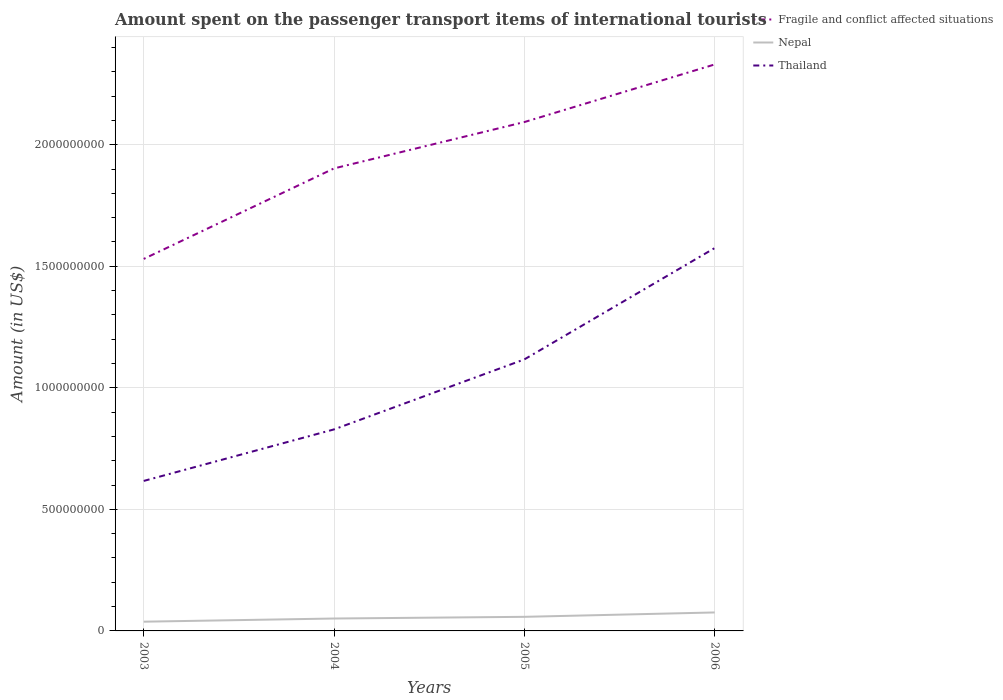Is the number of lines equal to the number of legend labels?
Offer a very short reply. Yes. Across all years, what is the maximum amount spent on the passenger transport items of international tourists in Nepal?
Provide a succinct answer. 3.80e+07. In which year was the amount spent on the passenger transport items of international tourists in Fragile and conflict affected situations maximum?
Your answer should be very brief. 2003. What is the total amount spent on the passenger transport items of international tourists in Nepal in the graph?
Your answer should be very brief. -1.30e+07. What is the difference between the highest and the second highest amount spent on the passenger transport items of international tourists in Fragile and conflict affected situations?
Provide a succinct answer. 8.00e+08. Is the amount spent on the passenger transport items of international tourists in Nepal strictly greater than the amount spent on the passenger transport items of international tourists in Fragile and conflict affected situations over the years?
Provide a succinct answer. Yes. How many lines are there?
Your answer should be compact. 3. Are the values on the major ticks of Y-axis written in scientific E-notation?
Offer a terse response. No. What is the title of the graph?
Your answer should be very brief. Amount spent on the passenger transport items of international tourists. Does "Gambia, The" appear as one of the legend labels in the graph?
Give a very brief answer. No. What is the Amount (in US$) in Fragile and conflict affected situations in 2003?
Ensure brevity in your answer.  1.53e+09. What is the Amount (in US$) in Nepal in 2003?
Make the answer very short. 3.80e+07. What is the Amount (in US$) in Thailand in 2003?
Keep it short and to the point. 6.17e+08. What is the Amount (in US$) in Fragile and conflict affected situations in 2004?
Offer a terse response. 1.90e+09. What is the Amount (in US$) in Nepal in 2004?
Make the answer very short. 5.10e+07. What is the Amount (in US$) in Thailand in 2004?
Keep it short and to the point. 8.29e+08. What is the Amount (in US$) of Fragile and conflict affected situations in 2005?
Your answer should be very brief. 2.09e+09. What is the Amount (in US$) of Nepal in 2005?
Provide a succinct answer. 5.80e+07. What is the Amount (in US$) in Thailand in 2005?
Provide a succinct answer. 1.12e+09. What is the Amount (in US$) in Fragile and conflict affected situations in 2006?
Offer a very short reply. 2.33e+09. What is the Amount (in US$) in Nepal in 2006?
Your answer should be compact. 7.60e+07. What is the Amount (in US$) of Thailand in 2006?
Your answer should be compact. 1.58e+09. Across all years, what is the maximum Amount (in US$) of Fragile and conflict affected situations?
Keep it short and to the point. 2.33e+09. Across all years, what is the maximum Amount (in US$) of Nepal?
Your answer should be very brief. 7.60e+07. Across all years, what is the maximum Amount (in US$) in Thailand?
Offer a terse response. 1.58e+09. Across all years, what is the minimum Amount (in US$) of Fragile and conflict affected situations?
Offer a very short reply. 1.53e+09. Across all years, what is the minimum Amount (in US$) of Nepal?
Your answer should be very brief. 3.80e+07. Across all years, what is the minimum Amount (in US$) of Thailand?
Offer a very short reply. 6.17e+08. What is the total Amount (in US$) of Fragile and conflict affected situations in the graph?
Ensure brevity in your answer.  7.86e+09. What is the total Amount (in US$) in Nepal in the graph?
Keep it short and to the point. 2.23e+08. What is the total Amount (in US$) in Thailand in the graph?
Make the answer very short. 4.14e+09. What is the difference between the Amount (in US$) of Fragile and conflict affected situations in 2003 and that in 2004?
Make the answer very short. -3.72e+08. What is the difference between the Amount (in US$) in Nepal in 2003 and that in 2004?
Provide a succinct answer. -1.30e+07. What is the difference between the Amount (in US$) of Thailand in 2003 and that in 2004?
Give a very brief answer. -2.12e+08. What is the difference between the Amount (in US$) of Fragile and conflict affected situations in 2003 and that in 2005?
Your answer should be very brief. -5.63e+08. What is the difference between the Amount (in US$) of Nepal in 2003 and that in 2005?
Give a very brief answer. -2.00e+07. What is the difference between the Amount (in US$) of Thailand in 2003 and that in 2005?
Ensure brevity in your answer.  -5.00e+08. What is the difference between the Amount (in US$) in Fragile and conflict affected situations in 2003 and that in 2006?
Provide a succinct answer. -8.00e+08. What is the difference between the Amount (in US$) in Nepal in 2003 and that in 2006?
Provide a succinct answer. -3.80e+07. What is the difference between the Amount (in US$) of Thailand in 2003 and that in 2006?
Your answer should be very brief. -9.58e+08. What is the difference between the Amount (in US$) in Fragile and conflict affected situations in 2004 and that in 2005?
Offer a terse response. -1.91e+08. What is the difference between the Amount (in US$) of Nepal in 2004 and that in 2005?
Make the answer very short. -7.00e+06. What is the difference between the Amount (in US$) of Thailand in 2004 and that in 2005?
Provide a succinct answer. -2.88e+08. What is the difference between the Amount (in US$) of Fragile and conflict affected situations in 2004 and that in 2006?
Your answer should be very brief. -4.28e+08. What is the difference between the Amount (in US$) of Nepal in 2004 and that in 2006?
Offer a terse response. -2.50e+07. What is the difference between the Amount (in US$) in Thailand in 2004 and that in 2006?
Your answer should be compact. -7.46e+08. What is the difference between the Amount (in US$) of Fragile and conflict affected situations in 2005 and that in 2006?
Your answer should be very brief. -2.37e+08. What is the difference between the Amount (in US$) of Nepal in 2005 and that in 2006?
Provide a succinct answer. -1.80e+07. What is the difference between the Amount (in US$) in Thailand in 2005 and that in 2006?
Ensure brevity in your answer.  -4.58e+08. What is the difference between the Amount (in US$) in Fragile and conflict affected situations in 2003 and the Amount (in US$) in Nepal in 2004?
Keep it short and to the point. 1.48e+09. What is the difference between the Amount (in US$) in Fragile and conflict affected situations in 2003 and the Amount (in US$) in Thailand in 2004?
Offer a terse response. 7.01e+08. What is the difference between the Amount (in US$) of Nepal in 2003 and the Amount (in US$) of Thailand in 2004?
Provide a succinct answer. -7.91e+08. What is the difference between the Amount (in US$) of Fragile and conflict affected situations in 2003 and the Amount (in US$) of Nepal in 2005?
Keep it short and to the point. 1.47e+09. What is the difference between the Amount (in US$) of Fragile and conflict affected situations in 2003 and the Amount (in US$) of Thailand in 2005?
Ensure brevity in your answer.  4.13e+08. What is the difference between the Amount (in US$) in Nepal in 2003 and the Amount (in US$) in Thailand in 2005?
Keep it short and to the point. -1.08e+09. What is the difference between the Amount (in US$) in Fragile and conflict affected situations in 2003 and the Amount (in US$) in Nepal in 2006?
Offer a very short reply. 1.45e+09. What is the difference between the Amount (in US$) in Fragile and conflict affected situations in 2003 and the Amount (in US$) in Thailand in 2006?
Your answer should be compact. -4.47e+07. What is the difference between the Amount (in US$) in Nepal in 2003 and the Amount (in US$) in Thailand in 2006?
Provide a short and direct response. -1.54e+09. What is the difference between the Amount (in US$) in Fragile and conflict affected situations in 2004 and the Amount (in US$) in Nepal in 2005?
Your answer should be very brief. 1.84e+09. What is the difference between the Amount (in US$) of Fragile and conflict affected situations in 2004 and the Amount (in US$) of Thailand in 2005?
Ensure brevity in your answer.  7.86e+08. What is the difference between the Amount (in US$) of Nepal in 2004 and the Amount (in US$) of Thailand in 2005?
Give a very brief answer. -1.07e+09. What is the difference between the Amount (in US$) of Fragile and conflict affected situations in 2004 and the Amount (in US$) of Nepal in 2006?
Your answer should be very brief. 1.83e+09. What is the difference between the Amount (in US$) of Fragile and conflict affected situations in 2004 and the Amount (in US$) of Thailand in 2006?
Make the answer very short. 3.28e+08. What is the difference between the Amount (in US$) of Nepal in 2004 and the Amount (in US$) of Thailand in 2006?
Give a very brief answer. -1.52e+09. What is the difference between the Amount (in US$) in Fragile and conflict affected situations in 2005 and the Amount (in US$) in Nepal in 2006?
Offer a very short reply. 2.02e+09. What is the difference between the Amount (in US$) in Fragile and conflict affected situations in 2005 and the Amount (in US$) in Thailand in 2006?
Provide a short and direct response. 5.18e+08. What is the difference between the Amount (in US$) of Nepal in 2005 and the Amount (in US$) of Thailand in 2006?
Your answer should be very brief. -1.52e+09. What is the average Amount (in US$) in Fragile and conflict affected situations per year?
Ensure brevity in your answer.  1.96e+09. What is the average Amount (in US$) of Nepal per year?
Give a very brief answer. 5.58e+07. What is the average Amount (in US$) in Thailand per year?
Your answer should be compact. 1.03e+09. In the year 2003, what is the difference between the Amount (in US$) in Fragile and conflict affected situations and Amount (in US$) in Nepal?
Ensure brevity in your answer.  1.49e+09. In the year 2003, what is the difference between the Amount (in US$) in Fragile and conflict affected situations and Amount (in US$) in Thailand?
Your response must be concise. 9.13e+08. In the year 2003, what is the difference between the Amount (in US$) in Nepal and Amount (in US$) in Thailand?
Offer a very short reply. -5.79e+08. In the year 2004, what is the difference between the Amount (in US$) in Fragile and conflict affected situations and Amount (in US$) in Nepal?
Offer a terse response. 1.85e+09. In the year 2004, what is the difference between the Amount (in US$) of Fragile and conflict affected situations and Amount (in US$) of Thailand?
Provide a succinct answer. 1.07e+09. In the year 2004, what is the difference between the Amount (in US$) in Nepal and Amount (in US$) in Thailand?
Give a very brief answer. -7.78e+08. In the year 2005, what is the difference between the Amount (in US$) of Fragile and conflict affected situations and Amount (in US$) of Nepal?
Provide a short and direct response. 2.04e+09. In the year 2005, what is the difference between the Amount (in US$) of Fragile and conflict affected situations and Amount (in US$) of Thailand?
Ensure brevity in your answer.  9.76e+08. In the year 2005, what is the difference between the Amount (in US$) in Nepal and Amount (in US$) in Thailand?
Offer a terse response. -1.06e+09. In the year 2006, what is the difference between the Amount (in US$) in Fragile and conflict affected situations and Amount (in US$) in Nepal?
Your answer should be compact. 2.25e+09. In the year 2006, what is the difference between the Amount (in US$) of Fragile and conflict affected situations and Amount (in US$) of Thailand?
Ensure brevity in your answer.  7.55e+08. In the year 2006, what is the difference between the Amount (in US$) in Nepal and Amount (in US$) in Thailand?
Ensure brevity in your answer.  -1.50e+09. What is the ratio of the Amount (in US$) in Fragile and conflict affected situations in 2003 to that in 2004?
Your response must be concise. 0.8. What is the ratio of the Amount (in US$) of Nepal in 2003 to that in 2004?
Make the answer very short. 0.75. What is the ratio of the Amount (in US$) in Thailand in 2003 to that in 2004?
Your response must be concise. 0.74. What is the ratio of the Amount (in US$) of Fragile and conflict affected situations in 2003 to that in 2005?
Offer a terse response. 0.73. What is the ratio of the Amount (in US$) of Nepal in 2003 to that in 2005?
Provide a short and direct response. 0.66. What is the ratio of the Amount (in US$) of Thailand in 2003 to that in 2005?
Your answer should be very brief. 0.55. What is the ratio of the Amount (in US$) in Fragile and conflict affected situations in 2003 to that in 2006?
Make the answer very short. 0.66. What is the ratio of the Amount (in US$) in Thailand in 2003 to that in 2006?
Your response must be concise. 0.39. What is the ratio of the Amount (in US$) of Fragile and conflict affected situations in 2004 to that in 2005?
Ensure brevity in your answer.  0.91. What is the ratio of the Amount (in US$) in Nepal in 2004 to that in 2005?
Your answer should be very brief. 0.88. What is the ratio of the Amount (in US$) of Thailand in 2004 to that in 2005?
Offer a terse response. 0.74. What is the ratio of the Amount (in US$) of Fragile and conflict affected situations in 2004 to that in 2006?
Provide a succinct answer. 0.82. What is the ratio of the Amount (in US$) in Nepal in 2004 to that in 2006?
Offer a terse response. 0.67. What is the ratio of the Amount (in US$) of Thailand in 2004 to that in 2006?
Provide a short and direct response. 0.53. What is the ratio of the Amount (in US$) in Fragile and conflict affected situations in 2005 to that in 2006?
Your answer should be compact. 0.9. What is the ratio of the Amount (in US$) of Nepal in 2005 to that in 2006?
Provide a succinct answer. 0.76. What is the ratio of the Amount (in US$) of Thailand in 2005 to that in 2006?
Your answer should be compact. 0.71. What is the difference between the highest and the second highest Amount (in US$) in Fragile and conflict affected situations?
Provide a succinct answer. 2.37e+08. What is the difference between the highest and the second highest Amount (in US$) in Nepal?
Your answer should be compact. 1.80e+07. What is the difference between the highest and the second highest Amount (in US$) of Thailand?
Your answer should be compact. 4.58e+08. What is the difference between the highest and the lowest Amount (in US$) in Fragile and conflict affected situations?
Your answer should be very brief. 8.00e+08. What is the difference between the highest and the lowest Amount (in US$) in Nepal?
Offer a very short reply. 3.80e+07. What is the difference between the highest and the lowest Amount (in US$) of Thailand?
Your answer should be very brief. 9.58e+08. 